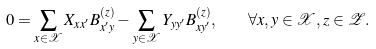<formula> <loc_0><loc_0><loc_500><loc_500>0 = \sum _ { x \in \mathcal { X } } X _ { x x ^ { \prime } } B _ { x ^ { \prime } y } ^ { ( z ) } - \sum _ { y \in \mathcal { X } } Y _ { y y ^ { \prime } } B _ { x y ^ { \prime } } ^ { ( z ) } , \quad \forall x , y \in \mathcal { X } , z \in \mathcal { Z } .</formula> 